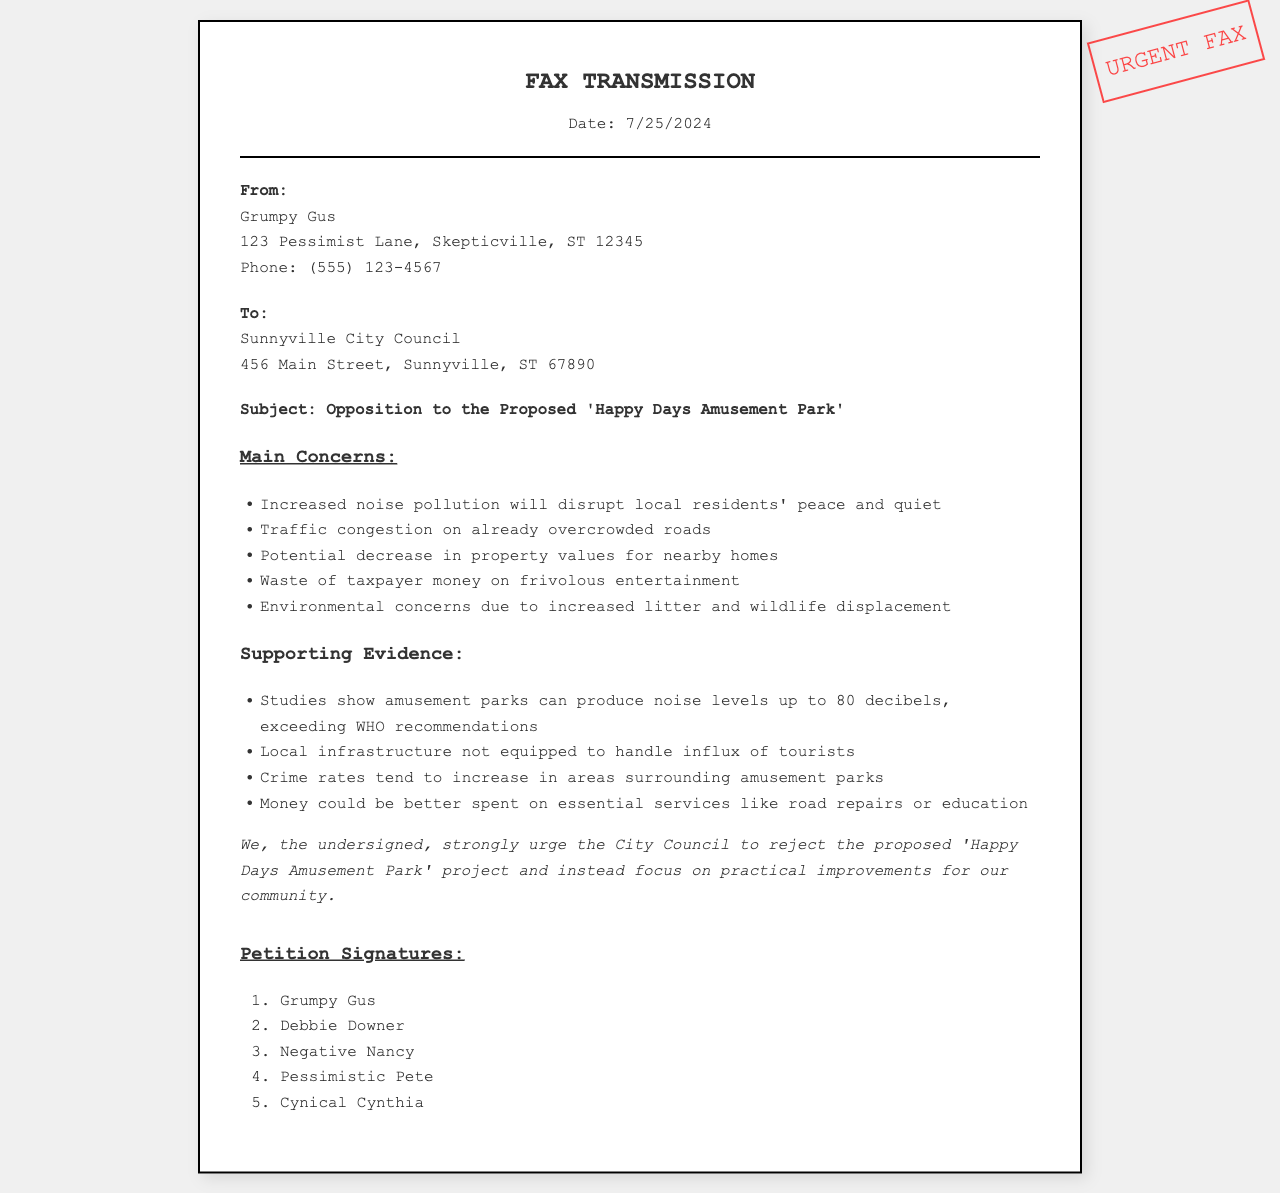What is the date of the fax? The date is indicated at the top of the fax document under the header with the value populated by a script.
Answer: Current date Who is the sender of the fax? The sender's information is specified in the sender-info section of the document.
Answer: Grumpy Gus What is the main concern regarding noise? The concern is listed in the main points about noise pollution affecting residents.
Answer: Increased noise pollution What is the proposed project the petition opposes? The subject of the fax explicitly states the project that is being opposed.
Answer: Happy Days Amusement Park What type of evidence is provided concerning noise levels? The supporting details outline specific studies related to noise levels and WHO recommendations.
Answer: Studies show amusement parks can produce noise levels up to 80 decibels How many signatures are listed in the petition? The total number of signatures is shown at the end of the document in the signatures section.
Answer: Five What does the petition suggest instead of the amusement park? The closing statement outlines an alternate focus suggested by the petitioners.
Answer: Practical improvements for our community What is the recipient of the fax? The recipient's information is provided in the recipient-info section of the document.
Answer: Sunnyville City Council What is mentioned as an alternative to spend money on? The supporting details suggest better uses for the funds rather than on entertainment.
Answer: Essential services like road repairs or education 